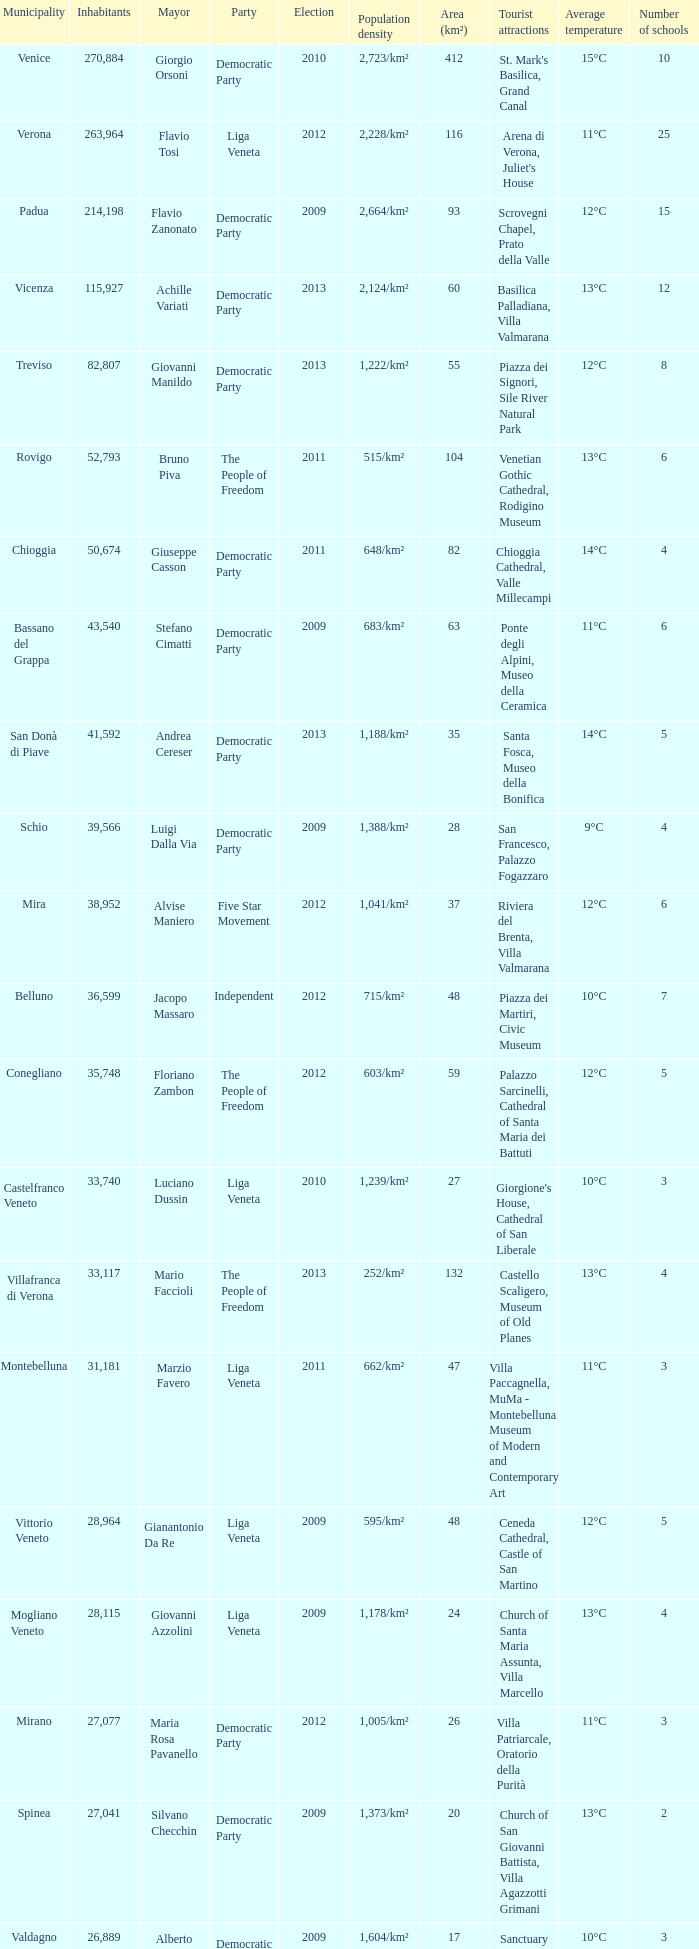In the election earlier than 2012 how many Inhabitants had a Party of five star movement? None. 